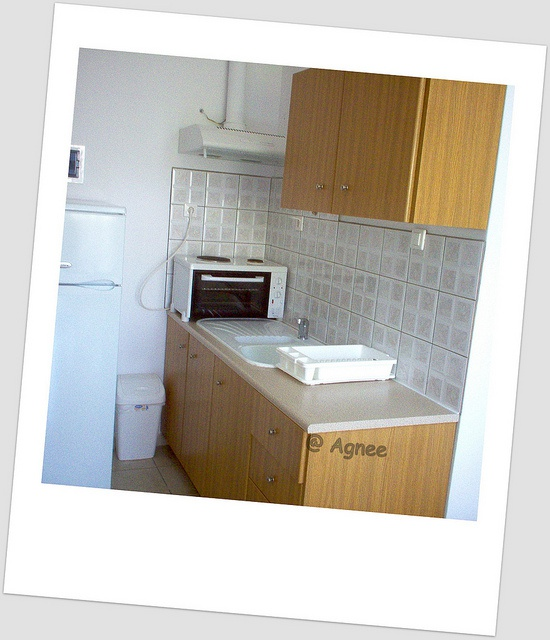Describe the objects in this image and their specific colors. I can see refrigerator in lightgray, lightblue, and darkgray tones, microwave in lightgray, black, darkgray, and lightblue tones, oven in lightgray, black, darkgray, and gray tones, and sink in lightgray, darkgray, and lightblue tones in this image. 